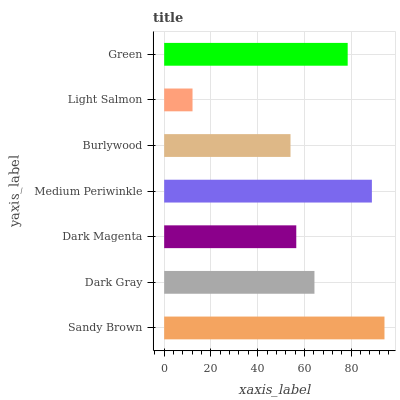Is Light Salmon the minimum?
Answer yes or no. Yes. Is Sandy Brown the maximum?
Answer yes or no. Yes. Is Dark Gray the minimum?
Answer yes or no. No. Is Dark Gray the maximum?
Answer yes or no. No. Is Sandy Brown greater than Dark Gray?
Answer yes or no. Yes. Is Dark Gray less than Sandy Brown?
Answer yes or no. Yes. Is Dark Gray greater than Sandy Brown?
Answer yes or no. No. Is Sandy Brown less than Dark Gray?
Answer yes or no. No. Is Dark Gray the high median?
Answer yes or no. Yes. Is Dark Gray the low median?
Answer yes or no. Yes. Is Medium Periwinkle the high median?
Answer yes or no. No. Is Sandy Brown the low median?
Answer yes or no. No. 